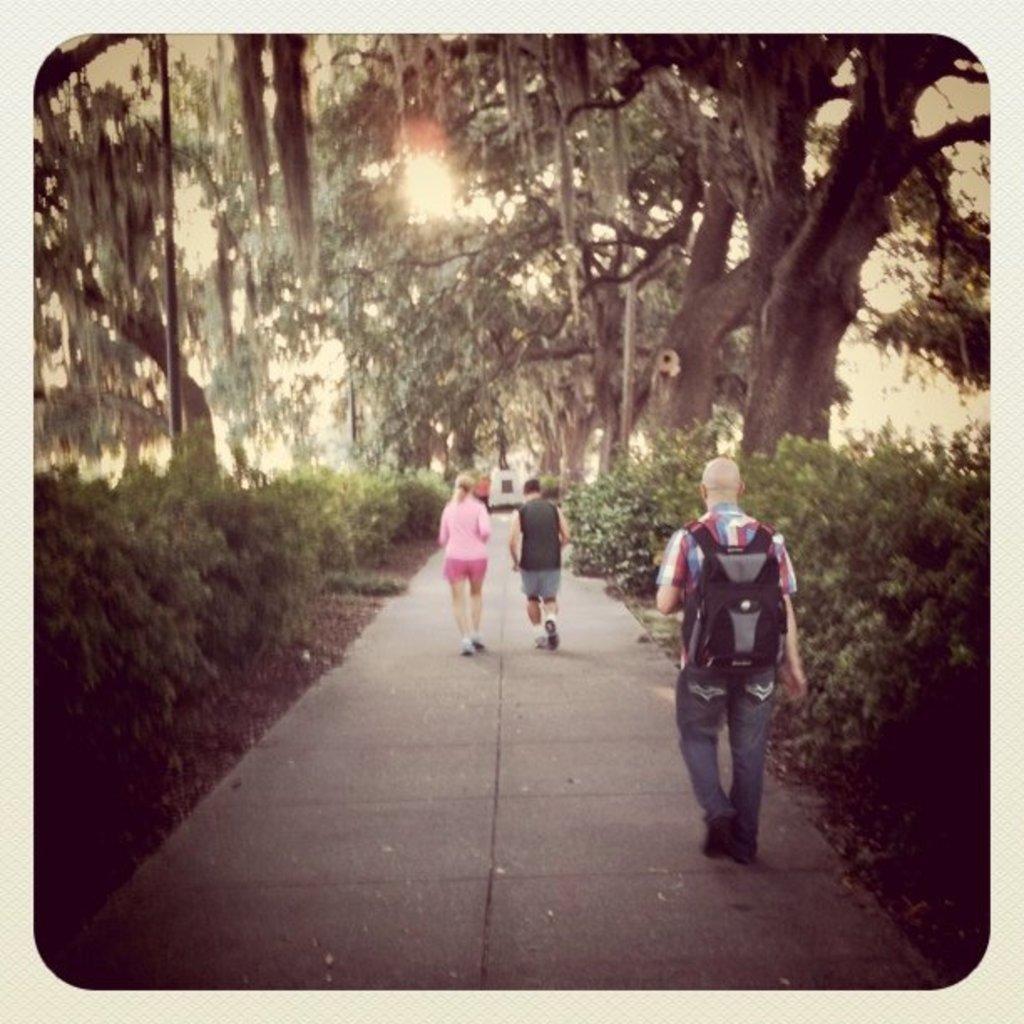Could you give a brief overview of what you see in this image? This picture shows few people walking and a man wore backpack on his back and we see trees and a statue. 